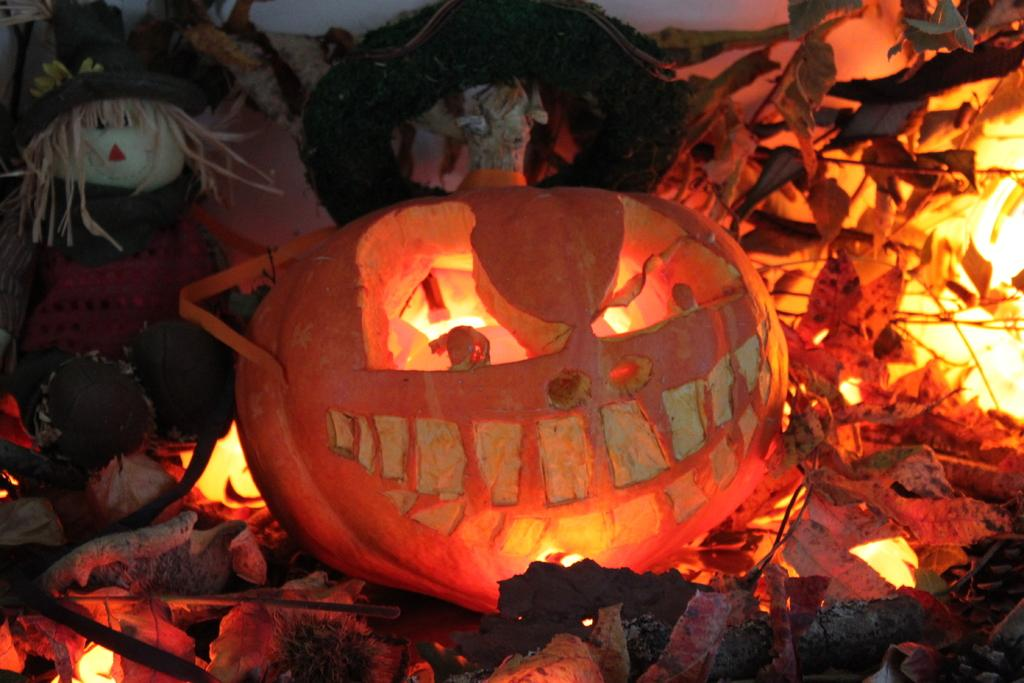What is the main object in the middle of the image? There is a pumpkin in the middle of the image. What else can be seen in the image besides the pumpkin? There are lights visible in the image. Where is the baby doll located in the image? The baby doll is on the top left side of the picture. How many flowers are present in the image? There are no flowers visible in the image. What type of cover is on the baby doll in the image? The baby doll in the image does not have a cover; it is a doll without any clothing or accessories. 